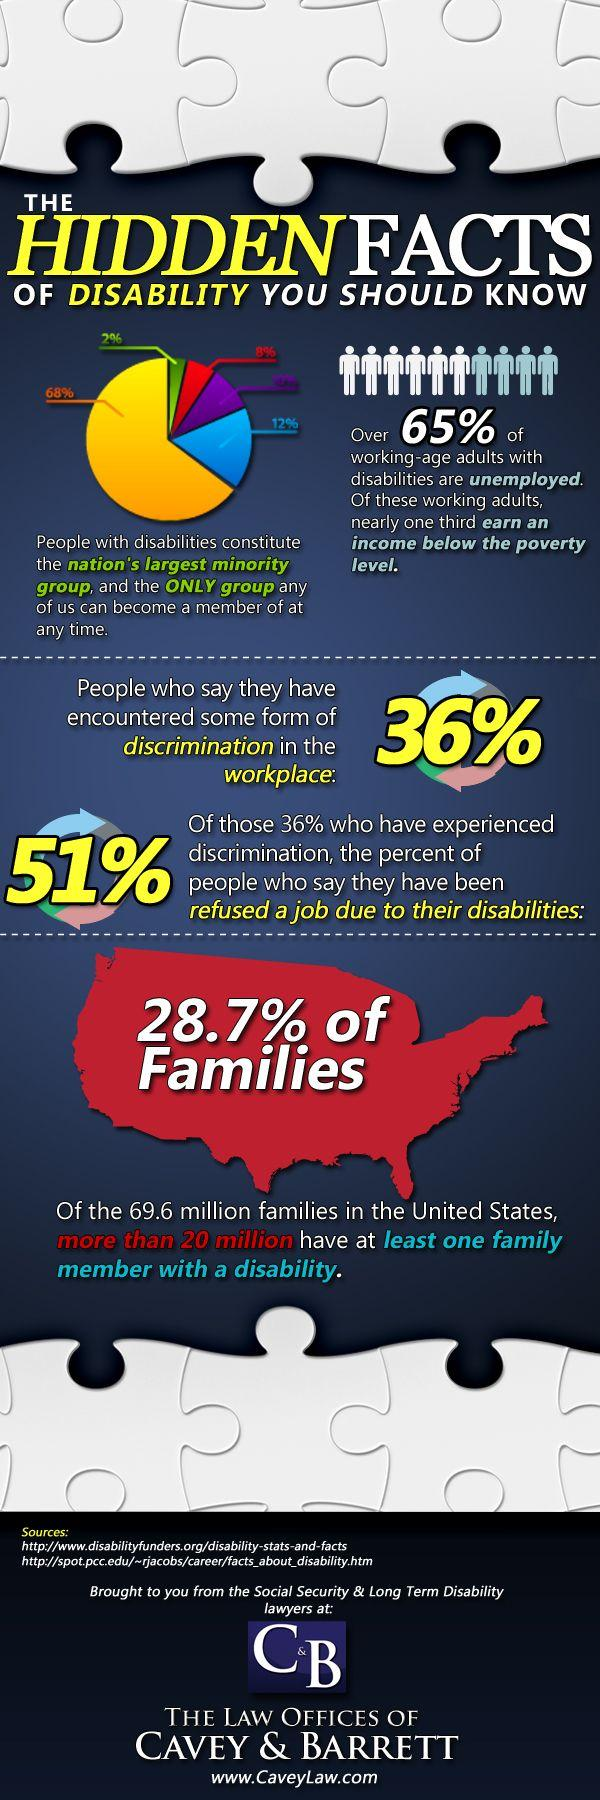Point out several critical features in this image. According to a recent survey, 51% of people with disabilities in the U.S. have been refused a job due to their disabilities. People with disabilities constitute the largest minority group in the United States. According to a recent survey, only 64% of people in the United States have not experienced any form of discrimination in the workplace. 